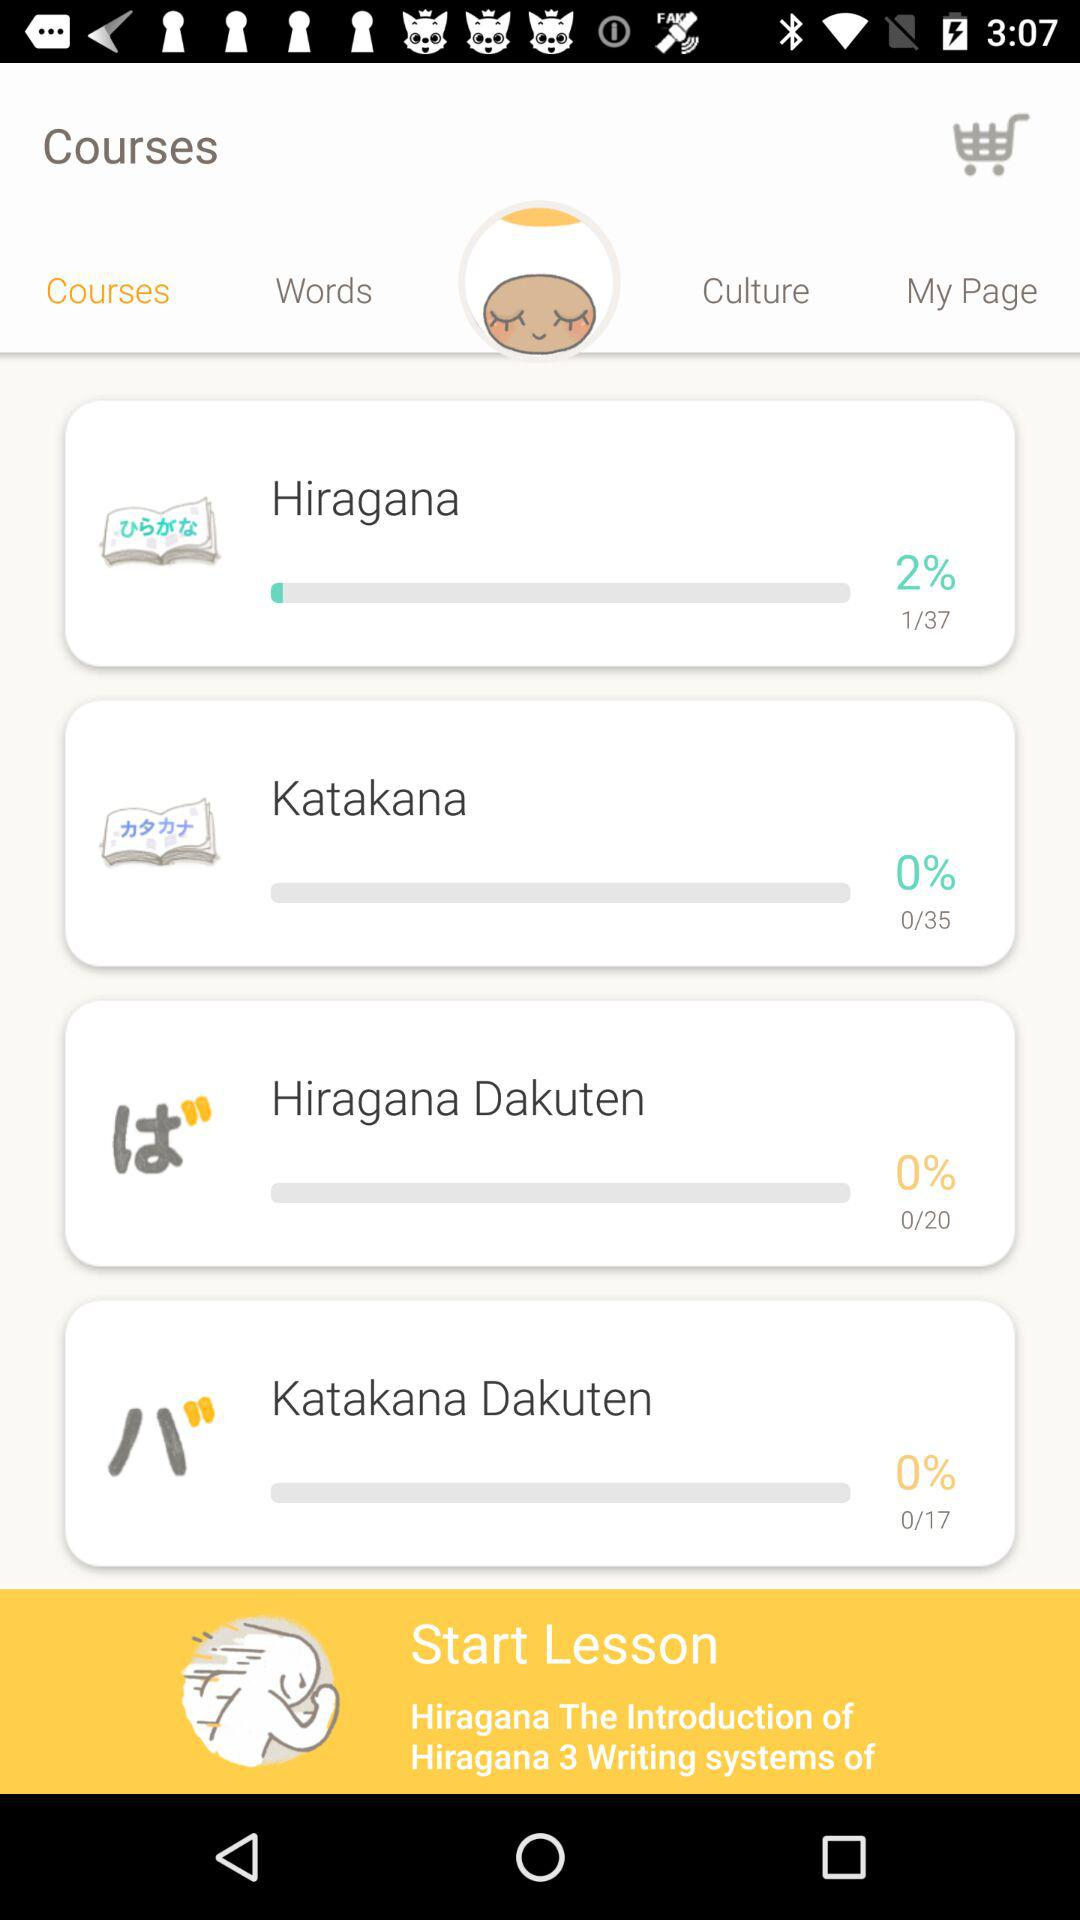What is the progress percentage of "Katakana"? The progress percentage is 0. 